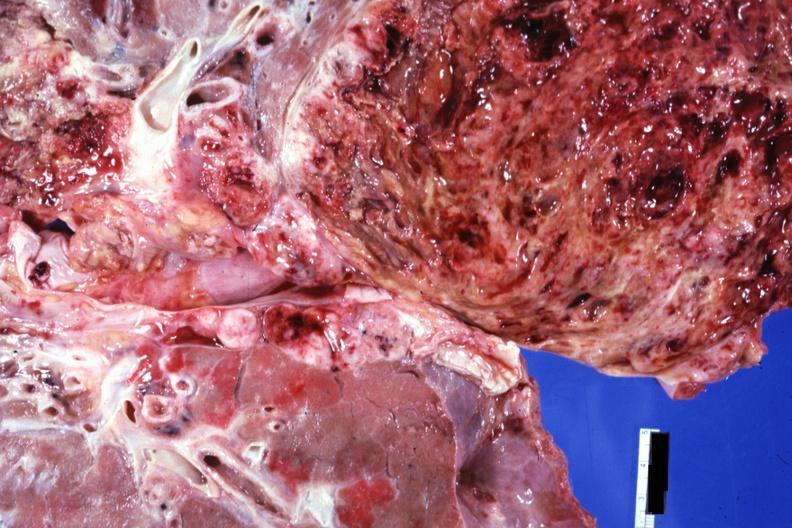what is present?
Answer the question using a single word or phrase. Teratocarcinoma 